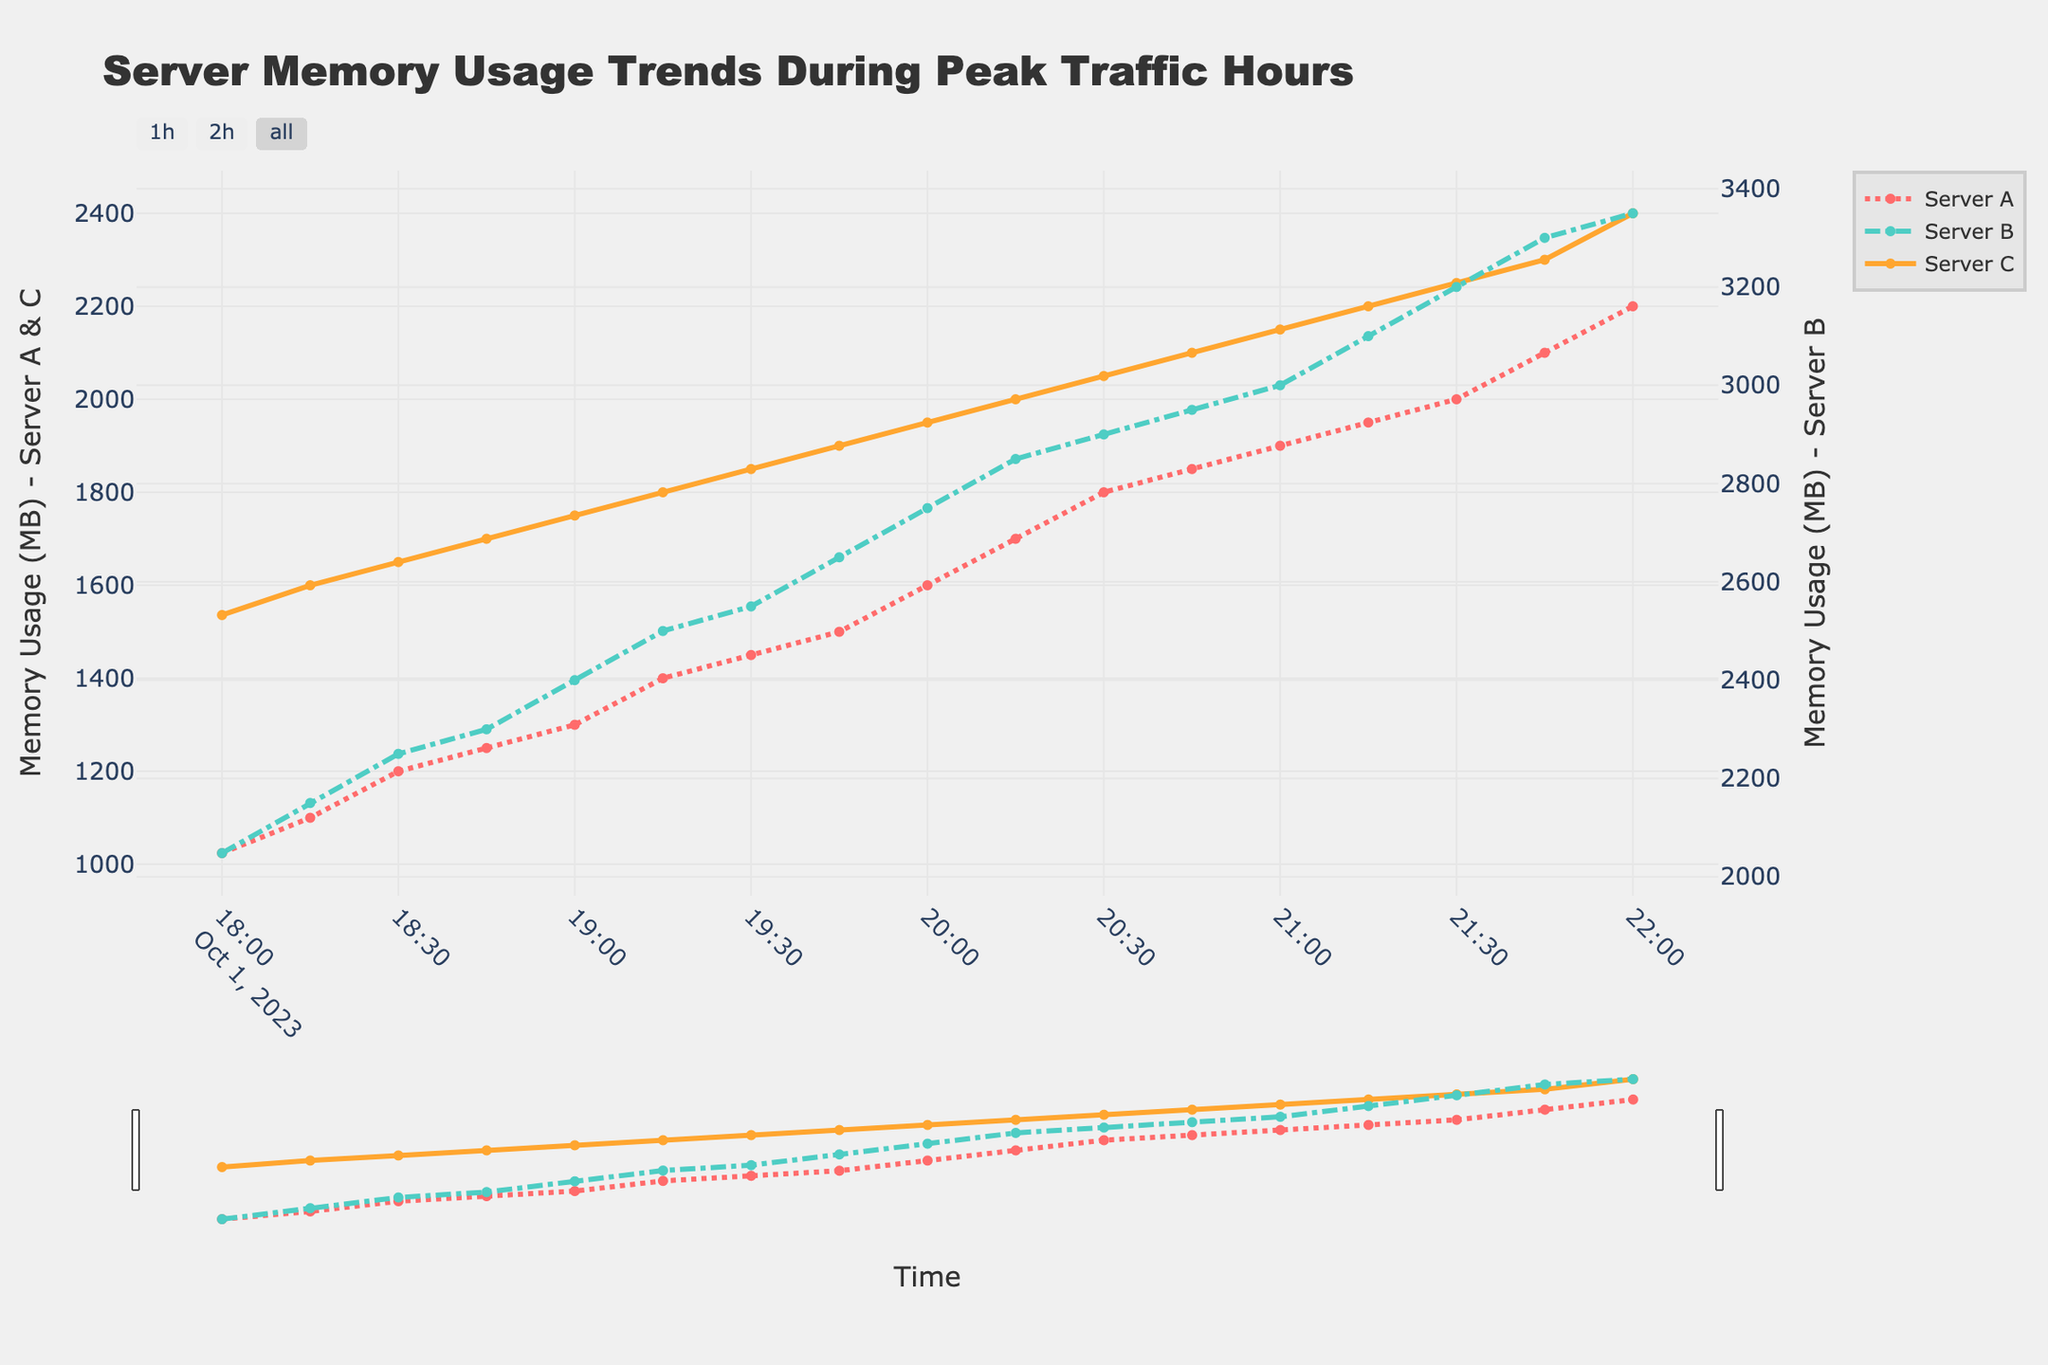What is the title of the figure? The title of the figure is prominently displayed at the top.
Answer: Server Memory Usage Trends During Peak Traffic Hours What is the color of the line representing Server A's memory usage? The color of the line for Server A is shown in the legend.
Answer: Red What was the memory usage for Server B at 20:30? Find the data point corresponding to Server B at the 20:30 timestamp to get the memory usage.
Answer: 2900 MB Which server had the highest memory usage at 22:00? Compare the memory usage values for all three servers at the 22:00 timestamp.
Answer: Server B What is the average memory usage of Server C from 18:00 to 22:00? Sum all data points for Server C and divide by the number of data points. Calculations: (1536 + 1600 + 1650 + 1700 + 1750 + 1800 + 1850 + 1900 + 1950 + 2000 + 2050 + 2100 + 2150 + 2200 + 2250 + 2300 + 2400) / 17
Answer: 1889 MB Did any server have a decreasing trend in memory usage during the given time period? Observe the trends for all three servers by looking at the plots over time.
Answer: No Which server showed the least variability in memory usage? Compare the range (maximum minus minimum values) of memory usage for each server.
Answer: Server C At which timestamps did Server A's memory usage exceed 1500 MB? Find timestamps on the x-axis where Server A’s memory usage crossed 1500 MB.
Answer: 20:00, 20:15, 20:30, 20:45, 21:00, 21:15, 21:30, 21:45, 22:00 What's the difference in memory usage between Server A and Server C at 19:00? Subtract the memory usage of Server C from Server A at the 19:00 timestamp.
Answer: -450 MB During which timeframe did Server B see the most significant increase in memory usage? Look at the intervals between the timestamps and identify where the slope of Server B's line is steepest.
Answer: 21:00 to 22:00 